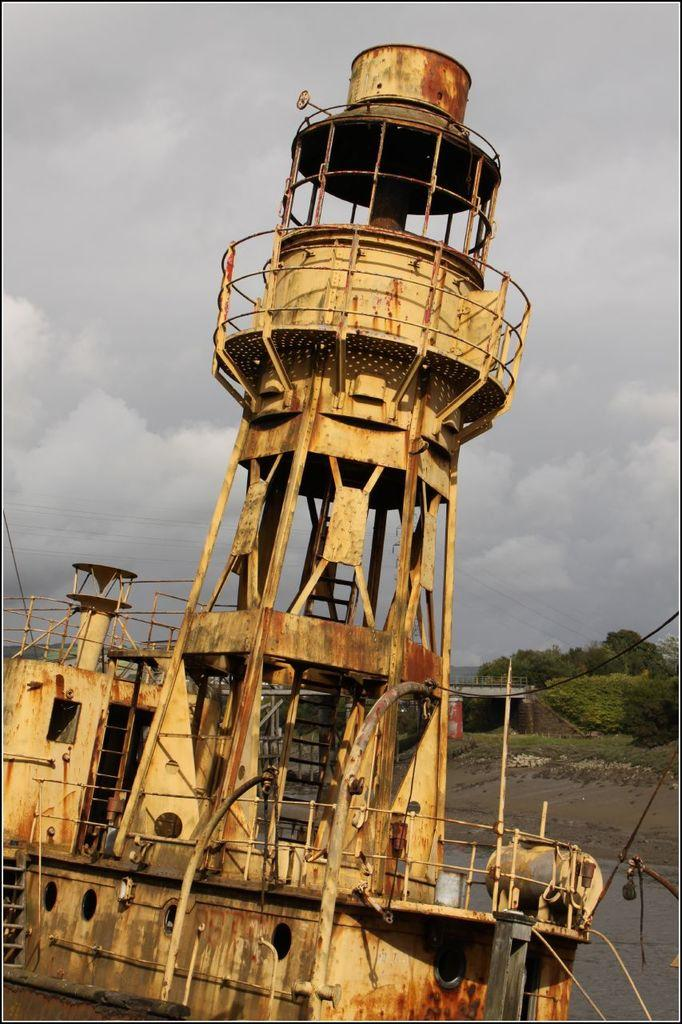What type of boat is in the image? There is a rusty boat in the image. Where is the boat located? The boat is in a lake. What can be seen behind the boat? There are trees behind the boat. What is visible above the boat? The sky is visible above the boat. What type of lamp is hanging from the side of the boat in the image? There is no lamp present in the image; it only features a rusty boat in a lake with trees behind it and the sky visible above it. 